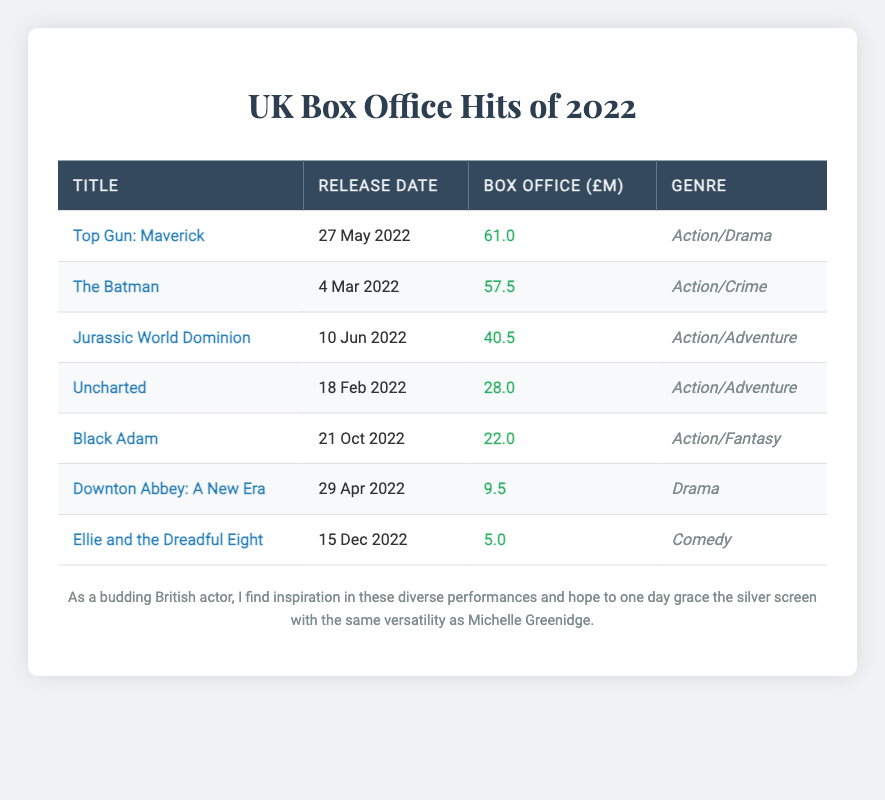What is the title of the film with the highest box office earnings? By looking at the box office earnings in the table, "Top Gun: Maverick" has the highest earnings at £61.0 million.
Answer: Top Gun: Maverick When was "Jurassic World Dominion" released? The release date for "Jurassic World Dominion" is listed in the table as June 10, 2022.
Answer: June 10, 2022 What is the total box office earnings of all the films listed in the table? To find the total, we add all the earnings together: 61.0 + 57.5 + 40.5 + 28.0 + 22.0 + 9.5 + 5.0 = 223.5 million.
Answer: 223.5 million Which genre had the film with the lowest earnings? "Ellie and the Dreadful Eight" is a Comedy with the lowest earnings of £5.0 million, making Comedy the genre with the lowest earnings.
Answer: Comedy Is "Black Adam" an Action film? Yes, "Black Adam" fits under the genre of Action/Fantasy, confirming it is indeed an Action film.
Answer: Yes What is the average box office earnings for the Action/Adventure genre? The total earnings for Action/Adventure films ("Jurassic World Dominion" - 40.5 and "Uncharted" - 28.0) is 40.5 + 28.0 = 68.5 million. Since there are 2 films in this genre, the average earnings is 68.5 / 2 = 34.25 million.
Answer: 34.25 million How many films were released before the summer of 2022? The films released before summer (before June) are "The Batman," "Uncharted," and "Downton Abbey: A New Era." This counts to 3 films.
Answer: 3 What is the difference in box office earnings between the highest and lowest earning films? The highest earning film is "Top Gun: Maverick" at £61.0 million and the lowest is "Ellie and the Dreadful Eight" at £5.0 million. The difference is 61.0 - 5.0 = 56.0 million.
Answer: 56.0 million Which film has the closest box office earnings to £30 million? "Uncharted" has earnings of £28.0 million, making it the closest to £30 million when compared to the earnings of other films in the table.
Answer: Uncharted 